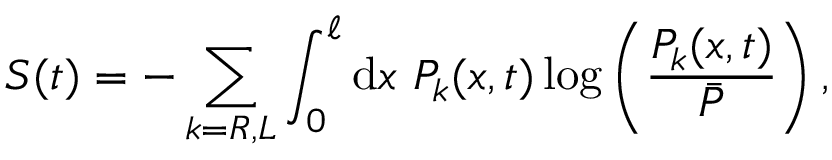<formula> <loc_0><loc_0><loc_500><loc_500>S ( t ) = - \sum _ { k = R , L } \int _ { 0 } ^ { \ell } d x P _ { k } ( x , t ) \log \left ( \frac { P _ { k } ( x , t ) } { \bar { P } } \right ) ,</formula> 